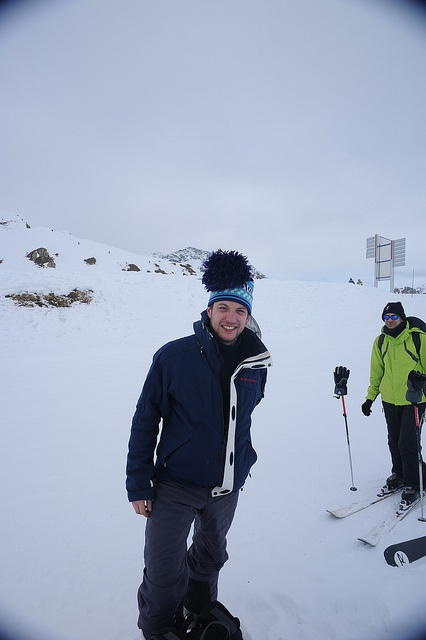Describe the objects in this image and their specific colors. I can see people in navy, black, gray, and darkgray tones, people in navy, black, and olive tones, skis in navy, darkgray, and gray tones, snowboard in navy, black, and darkgray tones, and skis in navy, black, and darkgray tones in this image. 